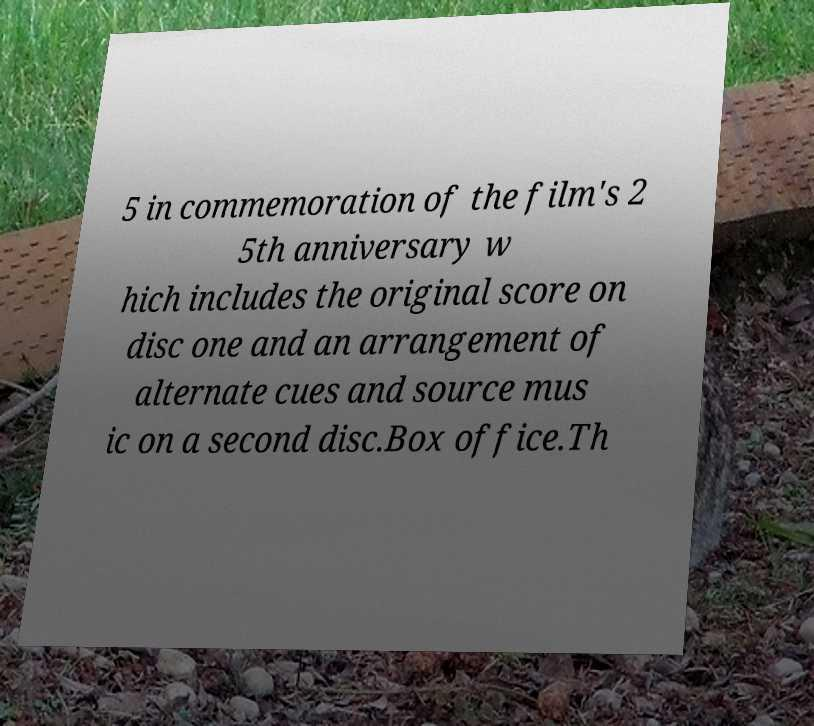There's text embedded in this image that I need extracted. Can you transcribe it verbatim? 5 in commemoration of the film's 2 5th anniversary w hich includes the original score on disc one and an arrangement of alternate cues and source mus ic on a second disc.Box office.Th 